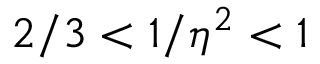<formula> <loc_0><loc_0><loc_500><loc_500>2 / 3 < 1 / \eta ^ { 2 } < 1</formula> 